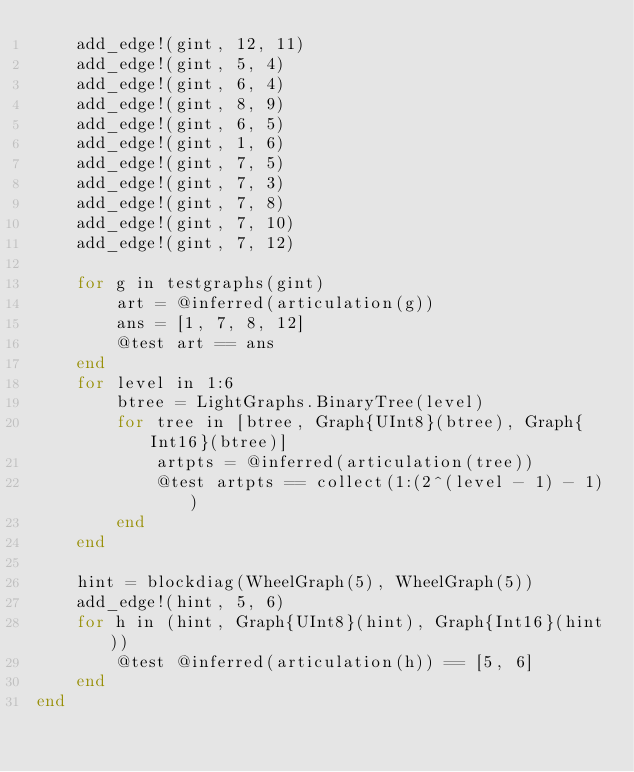<code> <loc_0><loc_0><loc_500><loc_500><_Julia_>    add_edge!(gint, 12, 11)
    add_edge!(gint, 5, 4)
    add_edge!(gint, 6, 4)
    add_edge!(gint, 8, 9)
    add_edge!(gint, 6, 5)
    add_edge!(gint, 1, 6)
    add_edge!(gint, 7, 5)
    add_edge!(gint, 7, 3)
    add_edge!(gint, 7, 8)
    add_edge!(gint, 7, 10)
    add_edge!(gint, 7, 12)

    for g in testgraphs(gint)
        art = @inferred(articulation(g))
        ans = [1, 7, 8, 12]
        @test art == ans
    end
    for level in 1:6
        btree = LightGraphs.BinaryTree(level)
        for tree in [btree, Graph{UInt8}(btree), Graph{Int16}(btree)]
            artpts = @inferred(articulation(tree))
            @test artpts == collect(1:(2^(level - 1) - 1))
        end
    end

    hint = blockdiag(WheelGraph(5), WheelGraph(5))
    add_edge!(hint, 5, 6)
    for h in (hint, Graph{UInt8}(hint), Graph{Int16}(hint))
        @test @inferred(articulation(h)) == [5, 6]
    end
end
</code> 